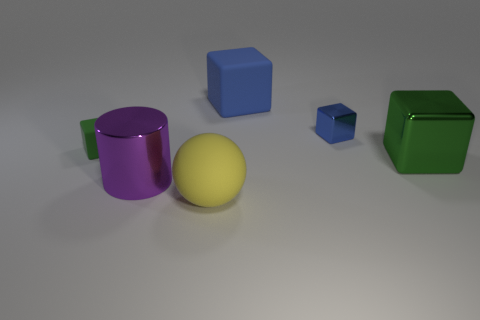Subtract all small metallic blocks. How many blocks are left? 3 Add 2 large yellow matte spheres. How many objects exist? 8 Subtract all purple cubes. Subtract all yellow cylinders. How many cubes are left? 4 Subtract all spheres. How many objects are left? 5 Add 3 matte balls. How many matte balls are left? 4 Add 4 red metallic balls. How many red metallic balls exist? 4 Subtract 0 cyan balls. How many objects are left? 6 Subtract all large metallic things. Subtract all big purple metallic cylinders. How many objects are left? 3 